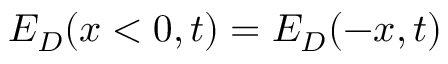<formula> <loc_0><loc_0><loc_500><loc_500>E _ { D } ( x < 0 , t ) = E _ { D } ( - x , t )</formula> 